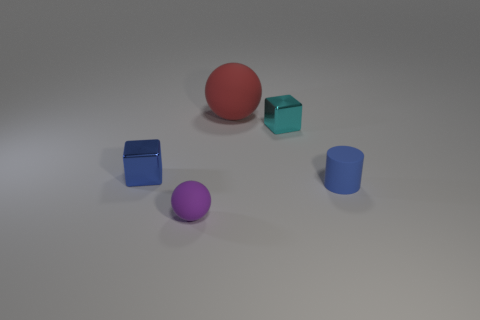There is a tiny metallic thing that is the same color as the cylinder; what is its shape?
Make the answer very short. Cube. Is there a tiny blue object made of the same material as the big red sphere?
Provide a short and direct response. Yes. The small purple object has what shape?
Your response must be concise. Sphere. How many yellow metal cylinders are there?
Make the answer very short. 0. There is a small matte thing that is to the right of the shiny block that is right of the small purple rubber thing; what color is it?
Provide a succinct answer. Blue. The matte thing that is the same size as the purple ball is what color?
Your answer should be very brief. Blue. Is there a tiny metallic object of the same color as the tiny cylinder?
Provide a short and direct response. Yes. Is there a tiny cyan metallic cylinder?
Provide a succinct answer. No. There is a small metal object that is to the right of the big matte sphere; what is its shape?
Keep it short and to the point. Cube. How many tiny cubes are both on the right side of the big matte ball and to the left of the small purple matte ball?
Your answer should be very brief. 0. 